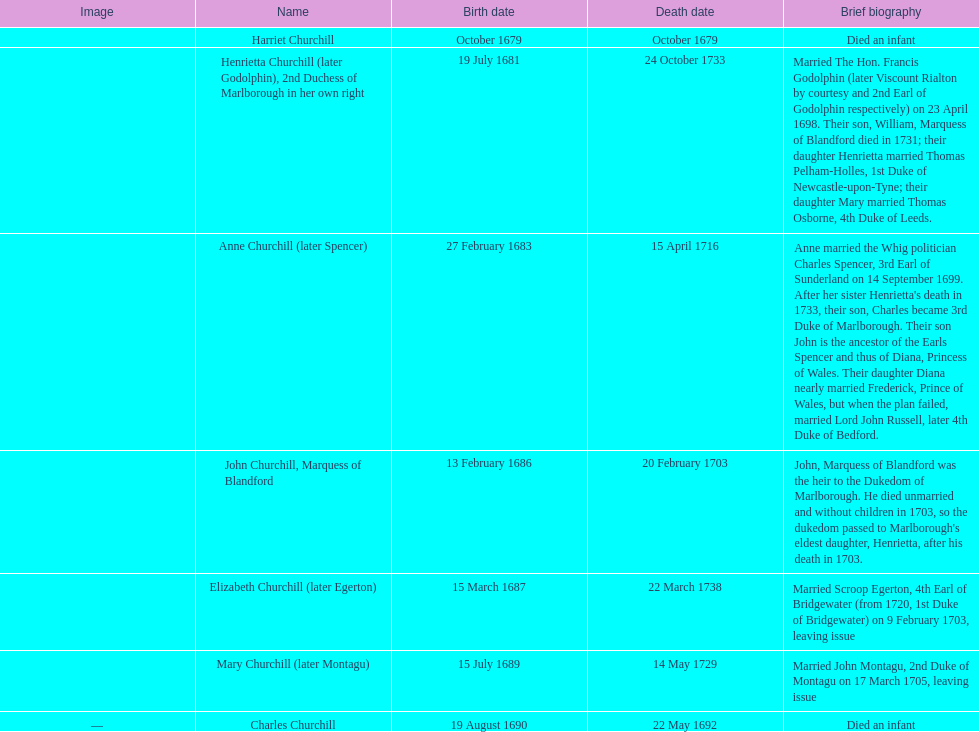What is the cumulative number of children born post-1675? 7. 